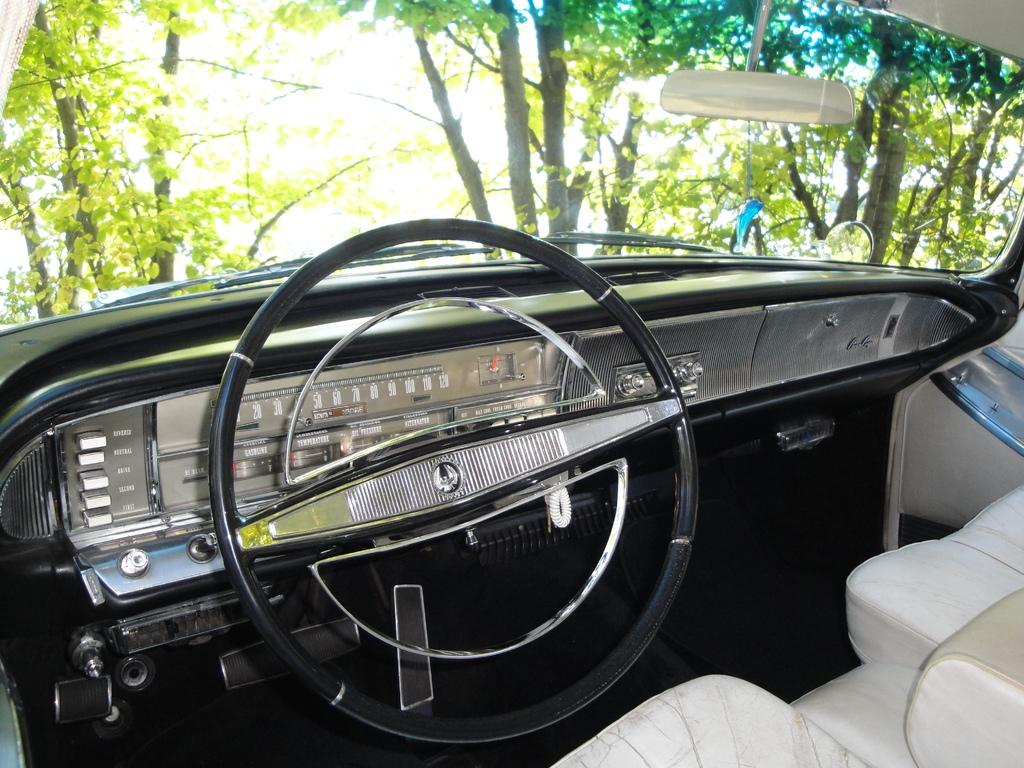What is the main object in the image? There is a steering wheel in the image. What else can be seen in the image besides the steering wheel? There are devices, a mirror, a windshield, seats, and trees visible through the windshield. What might be used for observing the surroundings in the image? The mirror and windshield can be used for observing the surroundings. What type of vegetation can be seen through the windshield? Trees are visible through the windshield. What type of alley can be seen in the image? There is no alley present in the image. 